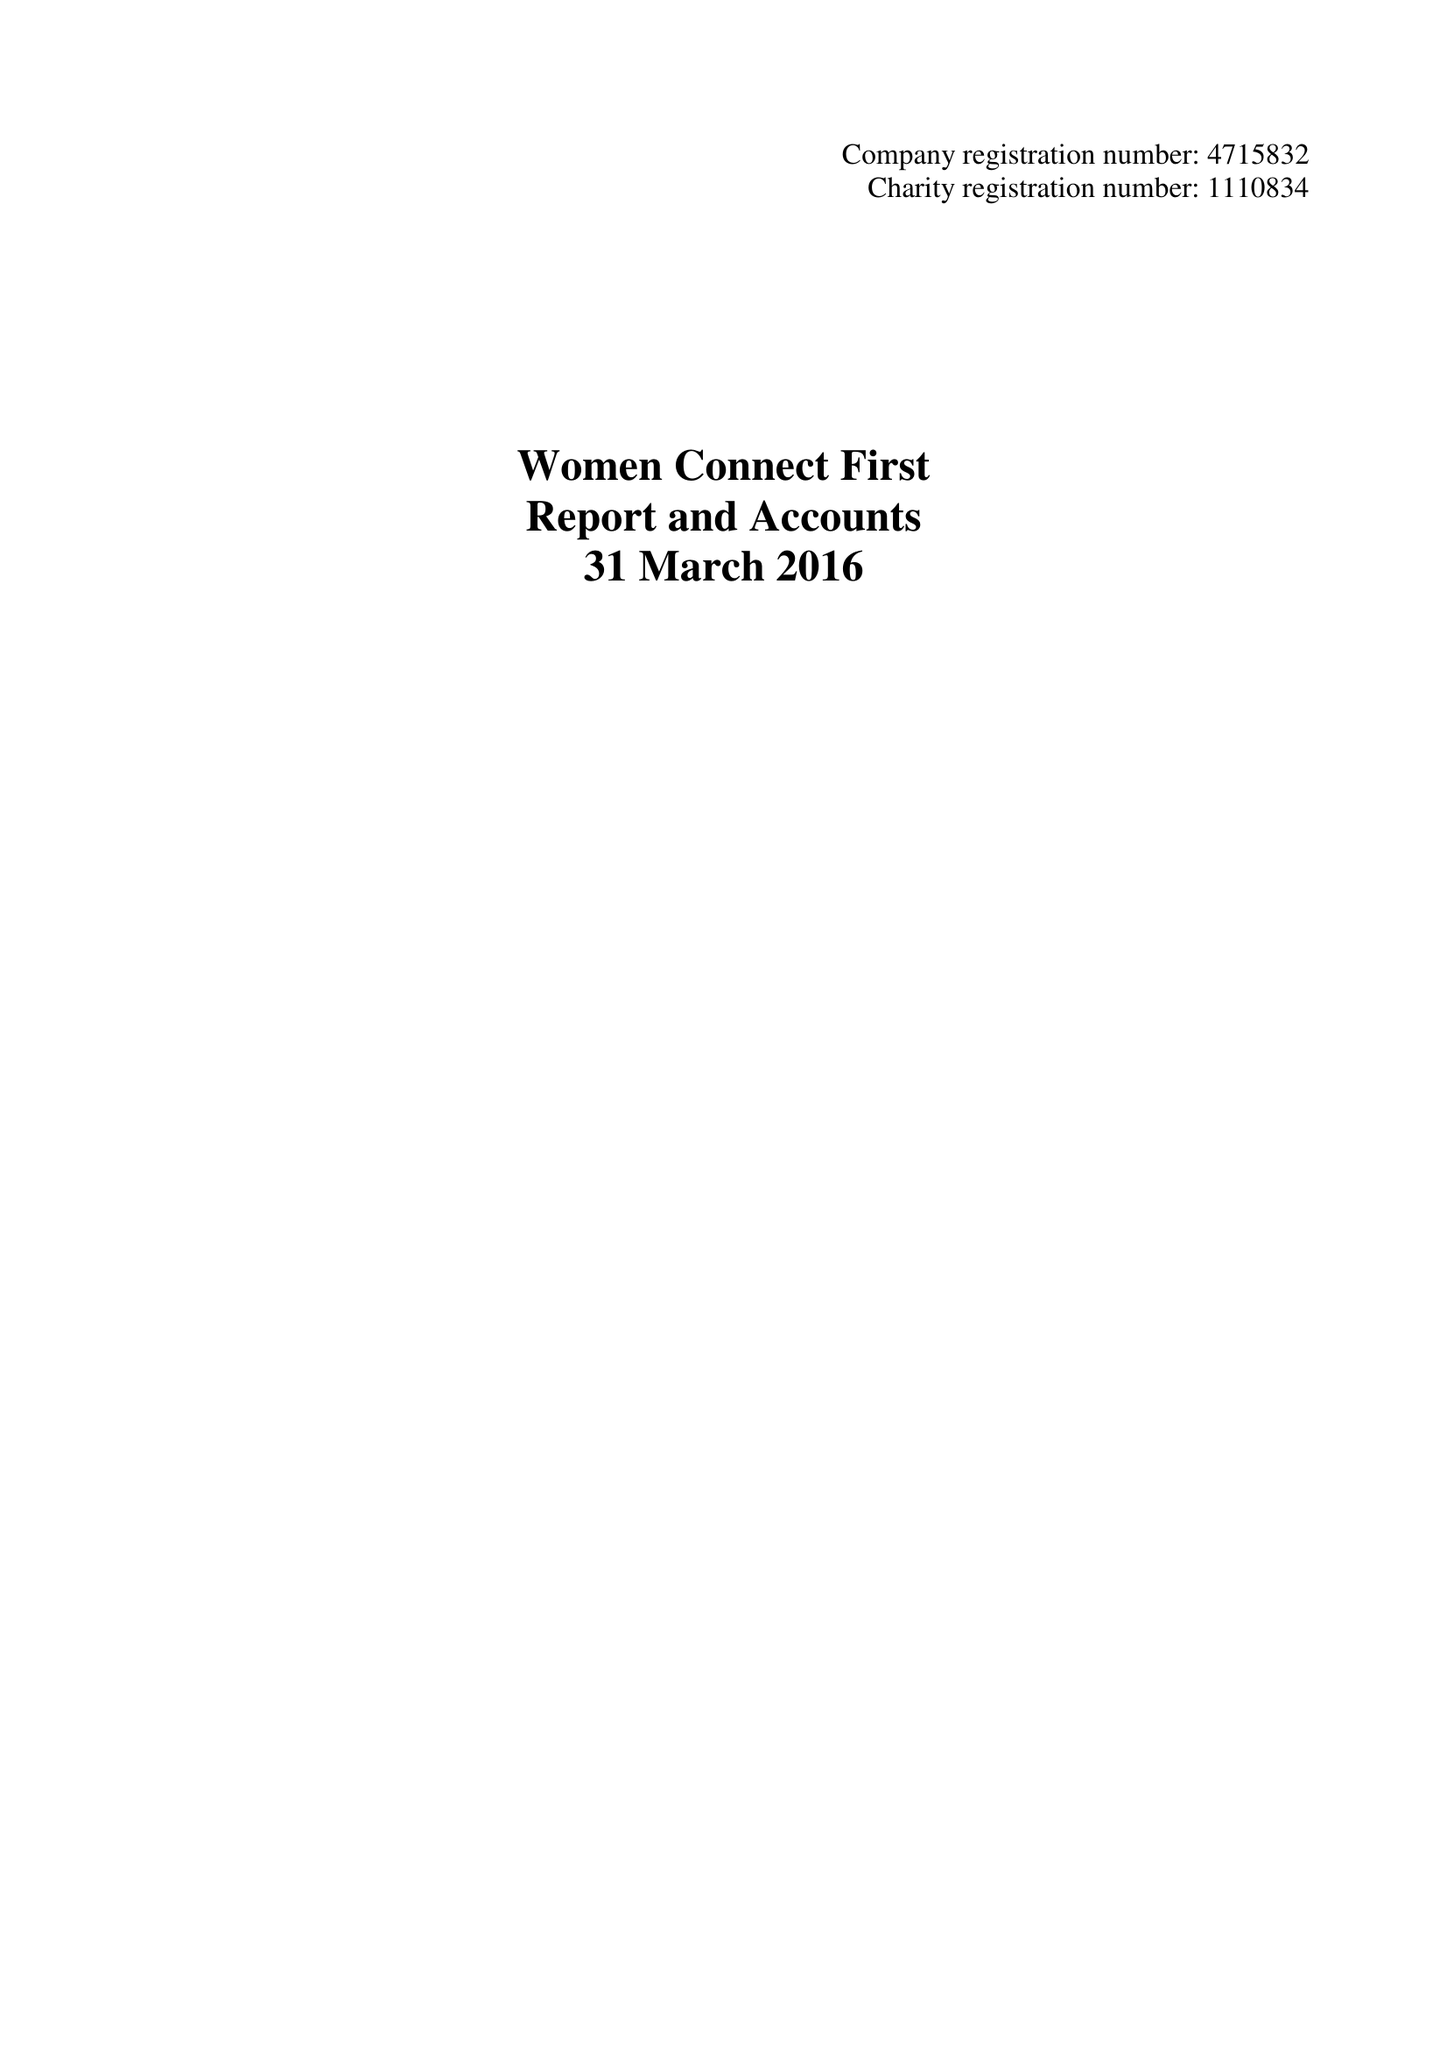What is the value for the report_date?
Answer the question using a single word or phrase. 2016-03-31 